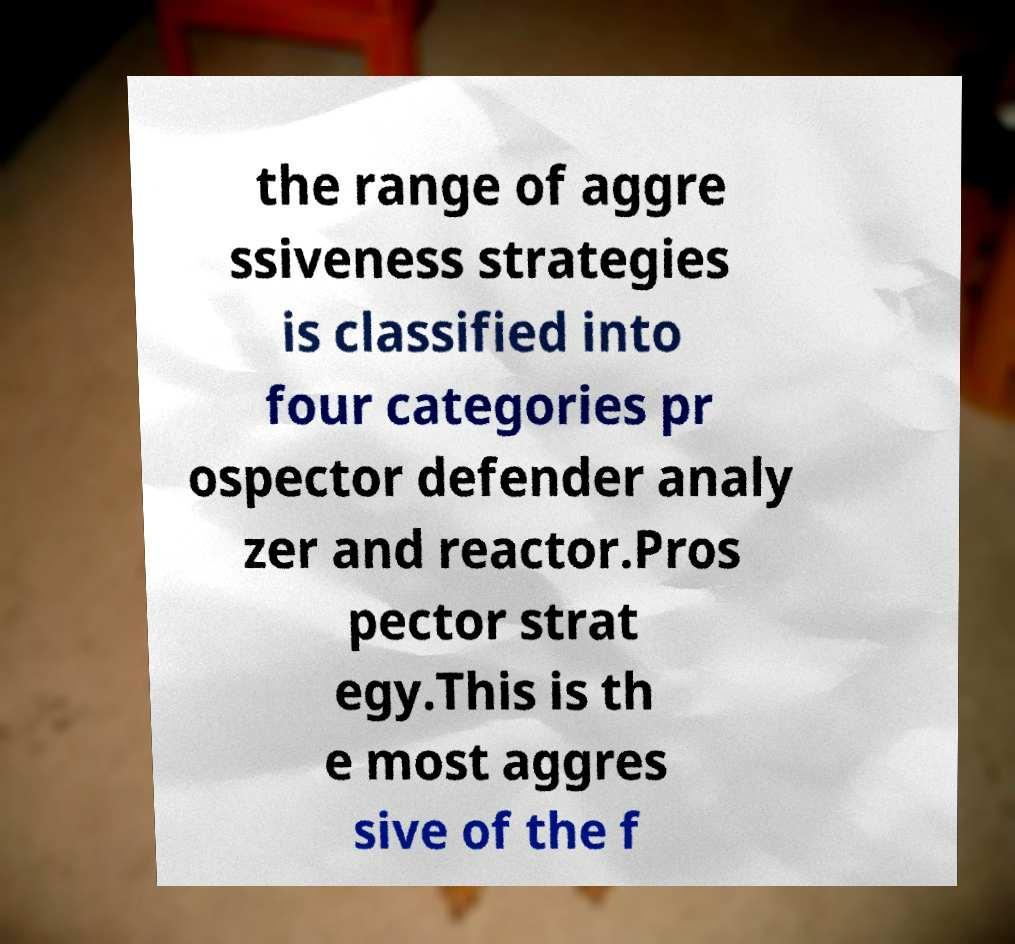Please identify and transcribe the text found in this image. the range of aggre ssiveness strategies is classified into four categories pr ospector defender analy zer and reactor.Pros pector strat egy.This is th e most aggres sive of the f 